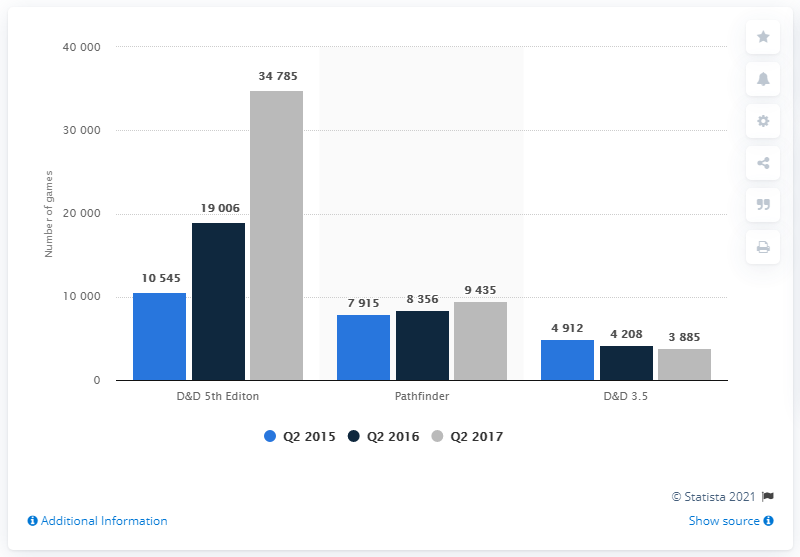Indicate a few pertinent items in this graphic. The value of the highest bar is 34785. The average score of Pathfinder is 8,568.67. In the second quarter of 2017, the digital version of D&D 5th Edition was played on Roll20 a total of 34,785 times. 